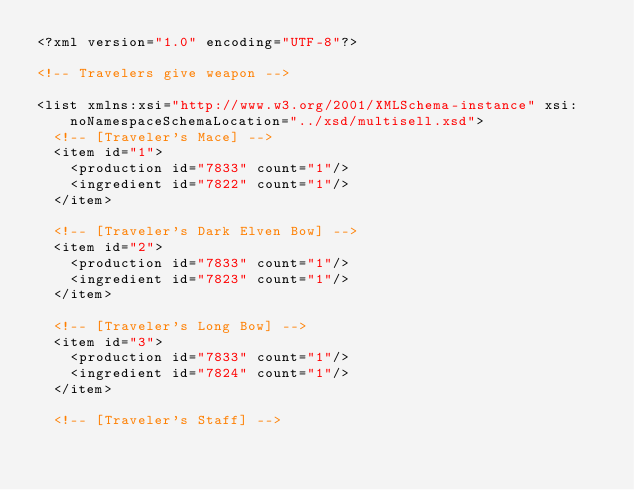Convert code to text. <code><loc_0><loc_0><loc_500><loc_500><_XML_><?xml version="1.0" encoding="UTF-8"?>

<!-- Travelers give weapon -->

<list xmlns:xsi="http://www.w3.org/2001/XMLSchema-instance" xsi:noNamespaceSchemaLocation="../xsd/multisell.xsd">
	<!-- [Traveler's Mace] -->
	<item id="1">
		<production id="7833" count="1"/>
		<ingredient id="7822" count="1"/>
	</item>

	<!-- [Traveler's Dark Elven Bow] -->
	<item id="2">
		<production id="7833" count="1"/>
		<ingredient id="7823" count="1"/>
	</item>

	<!-- [Traveler's Long Bow] -->
	<item id="3">
		<production id="7833" count="1"/>
		<ingredient id="7824" count="1"/>
	</item>

	<!-- [Traveler's Staff] --></code> 